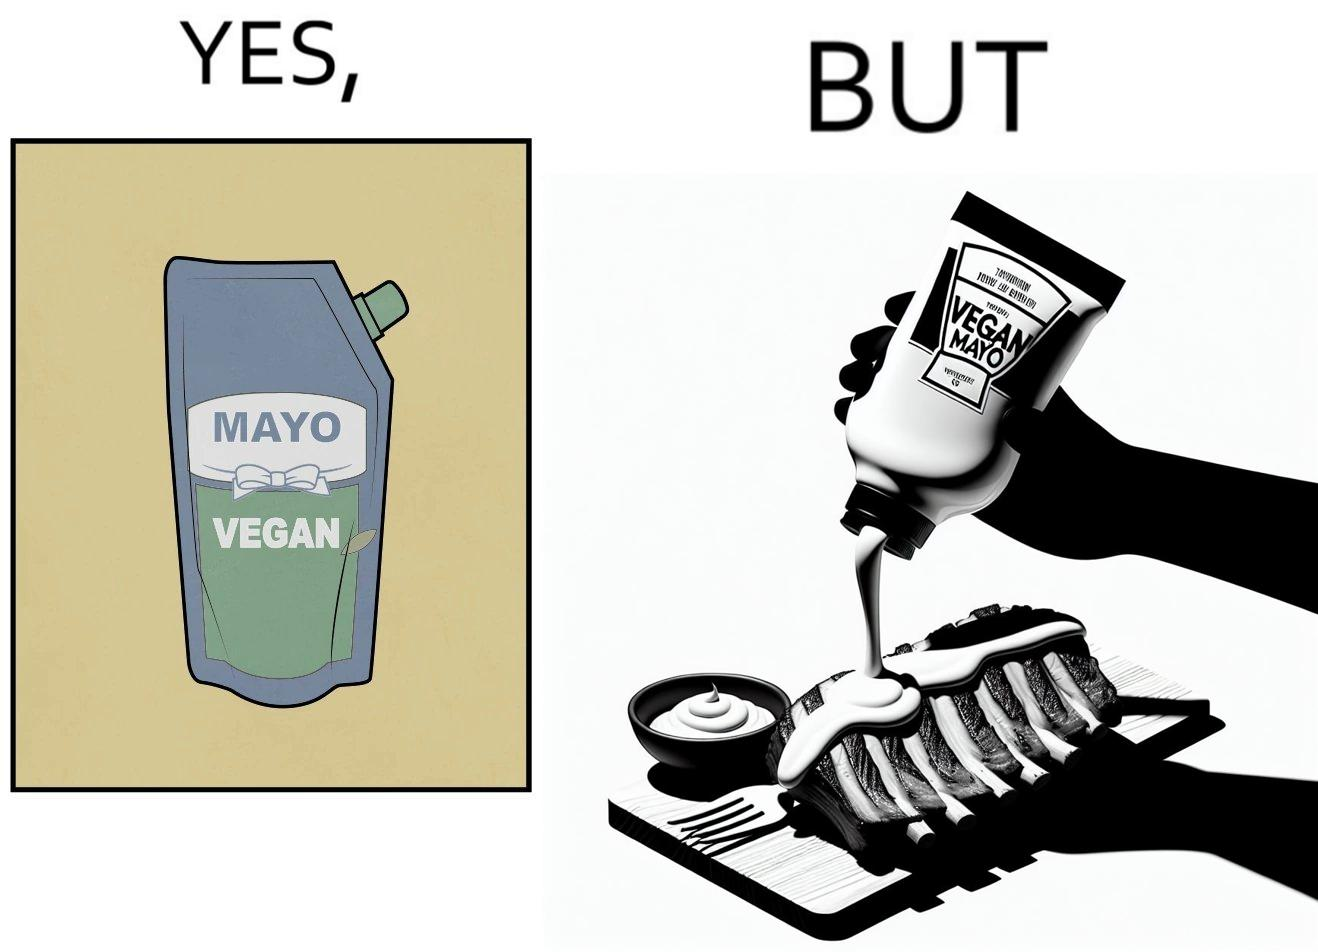Explain the humor or irony in this image. The image is ironical, as vegan mayo sauce is being poured on rib steak, which is non-vegetarian. The person might as well just use normal mayo sauce instead. 